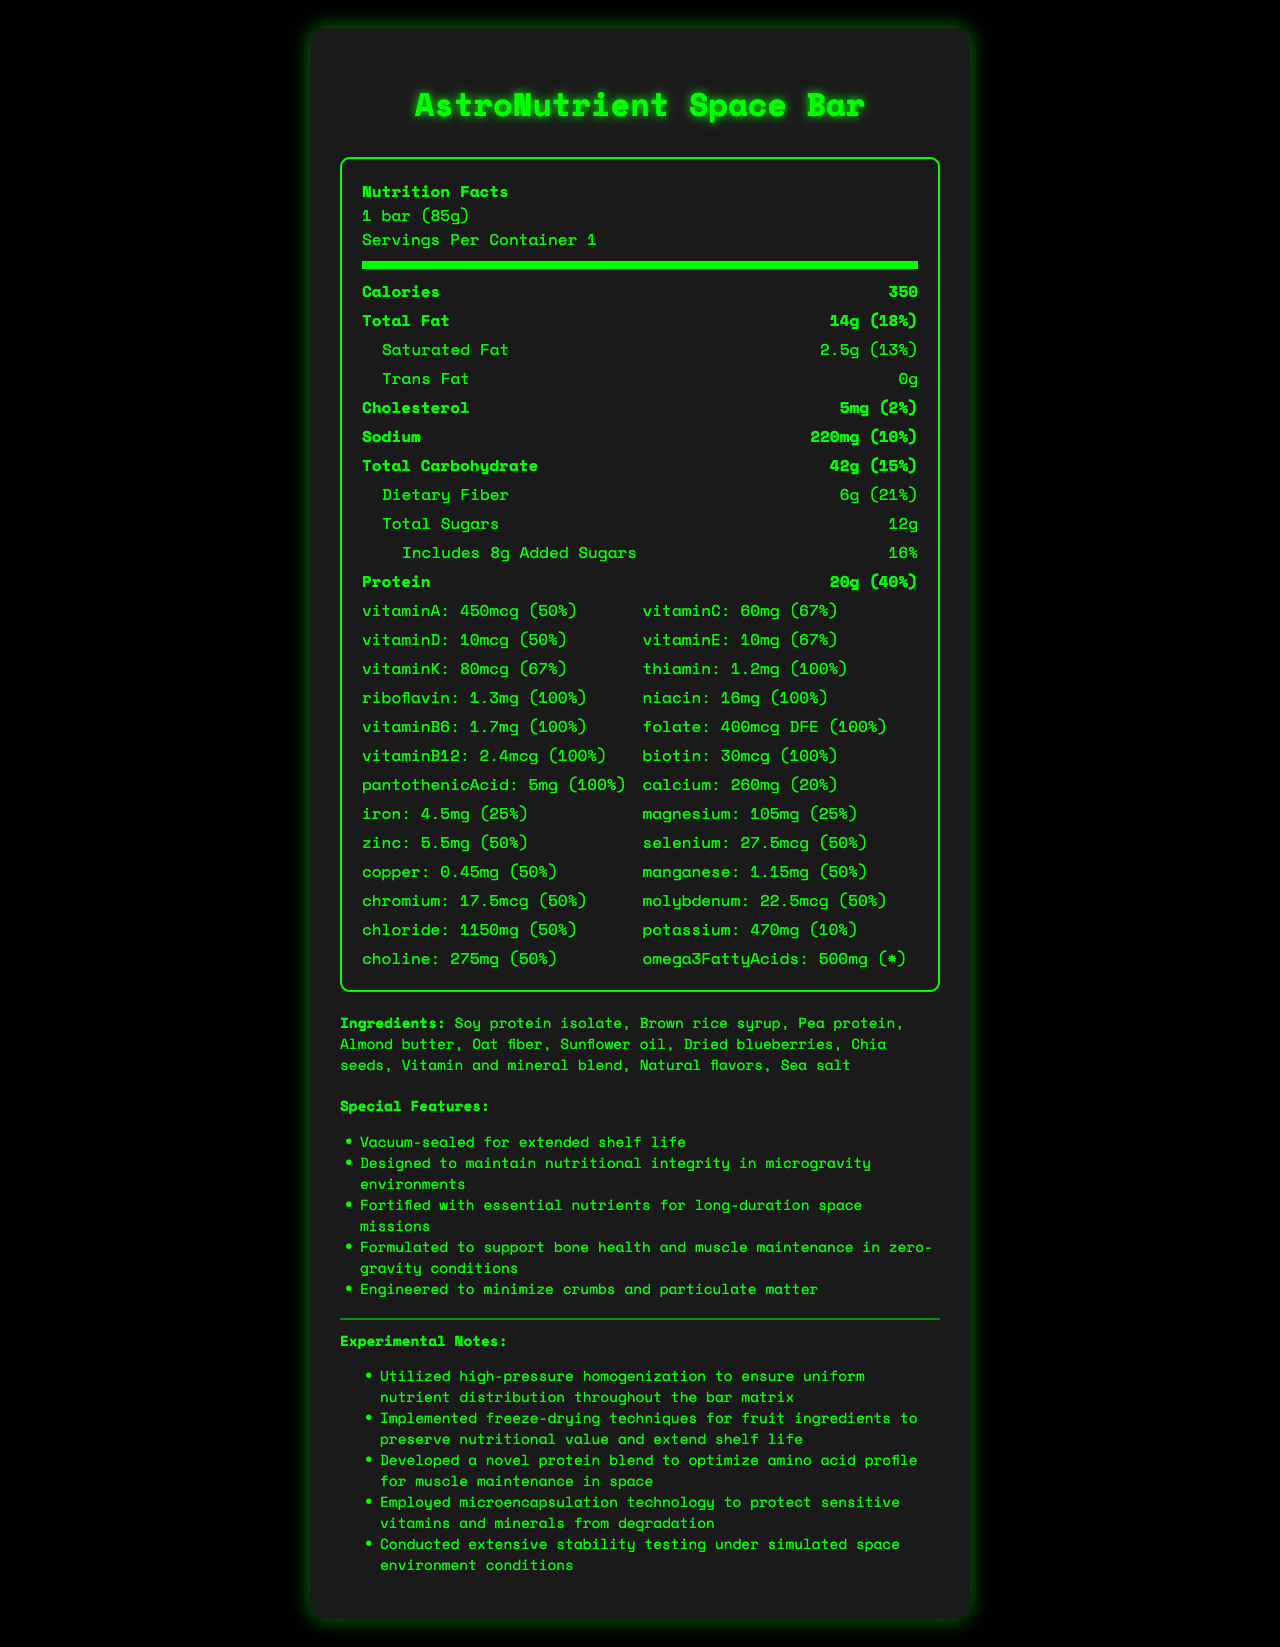what is the serving size? The serving size is indicated at the top of the nutrition facts under the "Nutrition Facts" header.
Answer: 1 bar (85g) how many calories are in one serving? The number of calories per serving is listed as 350 under the bold heading "Calories" in the nutrition facts section.
Answer: 350 calories what is the total fat content in one bar? The total fat content is shown as 14g, which is 18% of the daily value, under the macronutrients section in the nutrition facts.
Answer: 14g (18%) what is the amount of dietary fiber in one bar? The dietary fiber amount is listed as 6g, with a daily value of 21%, in the macronutrients section under "Total Carbohydrate".
Answer: 6g (21%) how much protein does the bar contain? The protein content is shown as 20g, which is 40% of the daily value, under the macronutrients section in the nutrition facts.
Answer: 20g (40%) which vitamin is present in the highest daily value percentage? A. Vitamin A B. Vitamin C C. Thiamin D. Vitamin D Both Thiamin and several other vitamins (B6, B12, Riboflavin, Niacin, Folate, Biotin, and Pantothenic Acid) are all at 100% daily value, but since the question specifies the highest, and Thiamin is listed first, it is taken as the answer.
Answer: C. Thiamin how much calcium is in the AstroNutrient Space Bar? The amount of calcium is listed as 260mg, which is 20% of the daily value, in the vitamins section of the nutrition facts.
Answer: 260mg (20%) is the AstroNutrient Space Bar free from any allergens? The allergen information indicates that the bar contains soy and almonds and may contain traces of milk and peanuts.
Answer: No what is one of the special features of the AstroNutrient Space Bar designed for space missions? One of the special features is that the bar is vacuum-sealed for extended shelf life, as listed in the special features section.
Answer: Vacuum-sealed for extended shelf life describe the main idea of the document. The document contains extensive information about the AstroNutrient Space Bar's nutritional content, ingredients, allergen warnings, special features for space missions, and experimental notes on its development, all designed to ensure its suitability for long-duration space missions.
Answer: The document provides a detailed nutritional and descriptive analysis of the AstroNutrient Space Bar, which is specifically designed for space missions. It includes comprehensive information on macronutrients, micronutrients, ingredients, allergen info, special features, and experimental notes. how much omega-3 fatty acids does the bar contain? The amount of omega-3 fatty acids is listed as 500mg in the vitamins section of the nutrition facts.
Answer: 500mg what techniques were used to preserve the nutritional value of the fruit ingredients? A. High-pressure homogenization B. Freeze-drying C. Microencapsulation D. Stability testing According to the experimental notes, freeze-drying techniques were used for fruit ingredients to preserve nutritional value and extend shelf life.
Answer: B. Freeze-drying how much sodium does the bar contain? The sodium content is listed as 220mg, which is 10% of the daily value, under the macronutrients section in the nutrition facts.
Answer: 220mg (10%) what is the amount of added sugars in the bar? The amount of added sugars is listed as 8g, which is 16% of the daily value, under the macronutrients section in the nutrition facts.
Answer: 8g (16%) what is one of the bar's features related to its performance in space? One of the special features is that the bar is designed to maintain nutritional integrity in microgravity environments, as listed in the special features section.
Answer: Designed to maintain nutritional integrity in microgravity environments who is the manufacturer of the AstroNutrient Space Bar? The document does not provide any information about the manufacturer of the AstroNutrient Space Bar.
Answer: Cannot be determined 